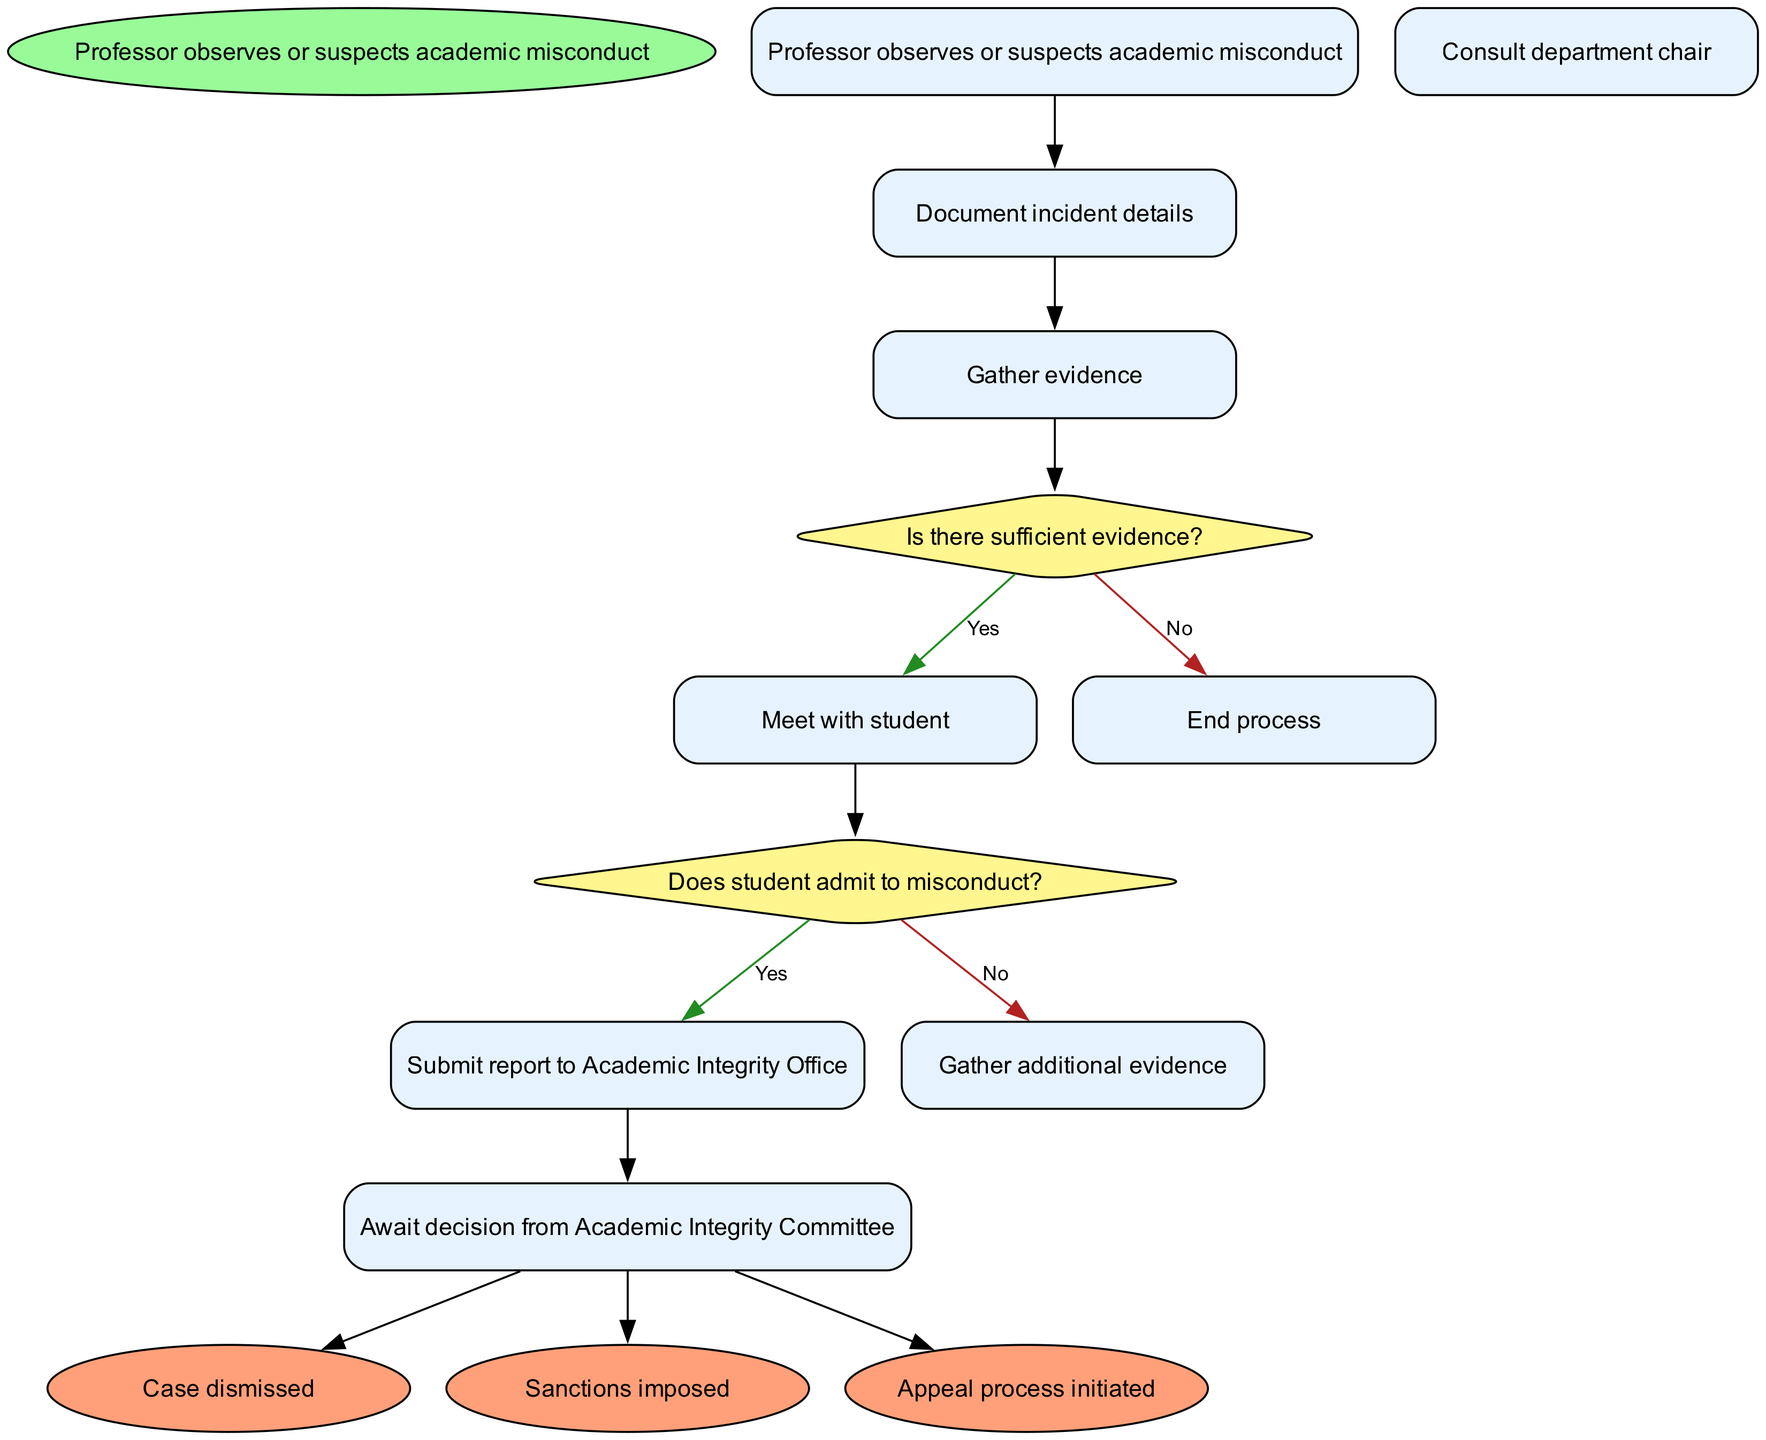What is the initial node in the process? The initial node in the process is clearly labeled as "Professor observes or suspects academic misconduct," and it is the starting point of the activity diagram.
Answer: Professor observes or suspects academic misconduct How many activities are there in the diagram? By counting the listed activities under the activities section, we find there are six distinct activities: "Document incident details," "Gather evidence," "Consult department chair," "Meet with student," "Submit report to Academic Integrity Office," and "Await decision from Academic Integrity Committee."
Answer: 6 What is the first activity that follows the initial node? The first activity that follows the initial node is indicated by the edge from the initial node to the next activity, which is "Document incident details."
Answer: Document incident details What happens if there is insufficient evidence? According to the decision section, if there is insufficient evidence as determined by the decision node "Is there sufficient evidence?", the process ends without further action.
Answer: End process What are the possible outcomes after the Academic Integrity Committee's decision? From the edges leading out of the "Await decision from Academic Integrity Committee" node, the possible outcomes are "Case dismissed," "Sanctions imposed," and "Appeal process initiated."
Answer: Case dismissed, Sanctions imposed, Appeal process initiated If a student admits to misconduct, what is the following step? The edge labeled with ‘Yes’ from the decision node "Does student admit to misconduct?" indicates that if a student admits to misconduct, the next step is to "Submit report to Academic Integrity Office."
Answer: Submit report to Academic Integrity Office How many decision nodes are present in the diagram? There are two decision nodes labeled: "Is there sufficient evidence?" and "Does student admit to misconduct?" This gives a total of two decision nodes in the diagram.
Answer: 2 What is the final node associated with a case being dismissed? The final node associated with a case being dismissed is labeled simply as "Case dismissed," which is one of the end outcomes after awaiting the Academic Integrity Committee's decision.
Answer: Case dismissed 